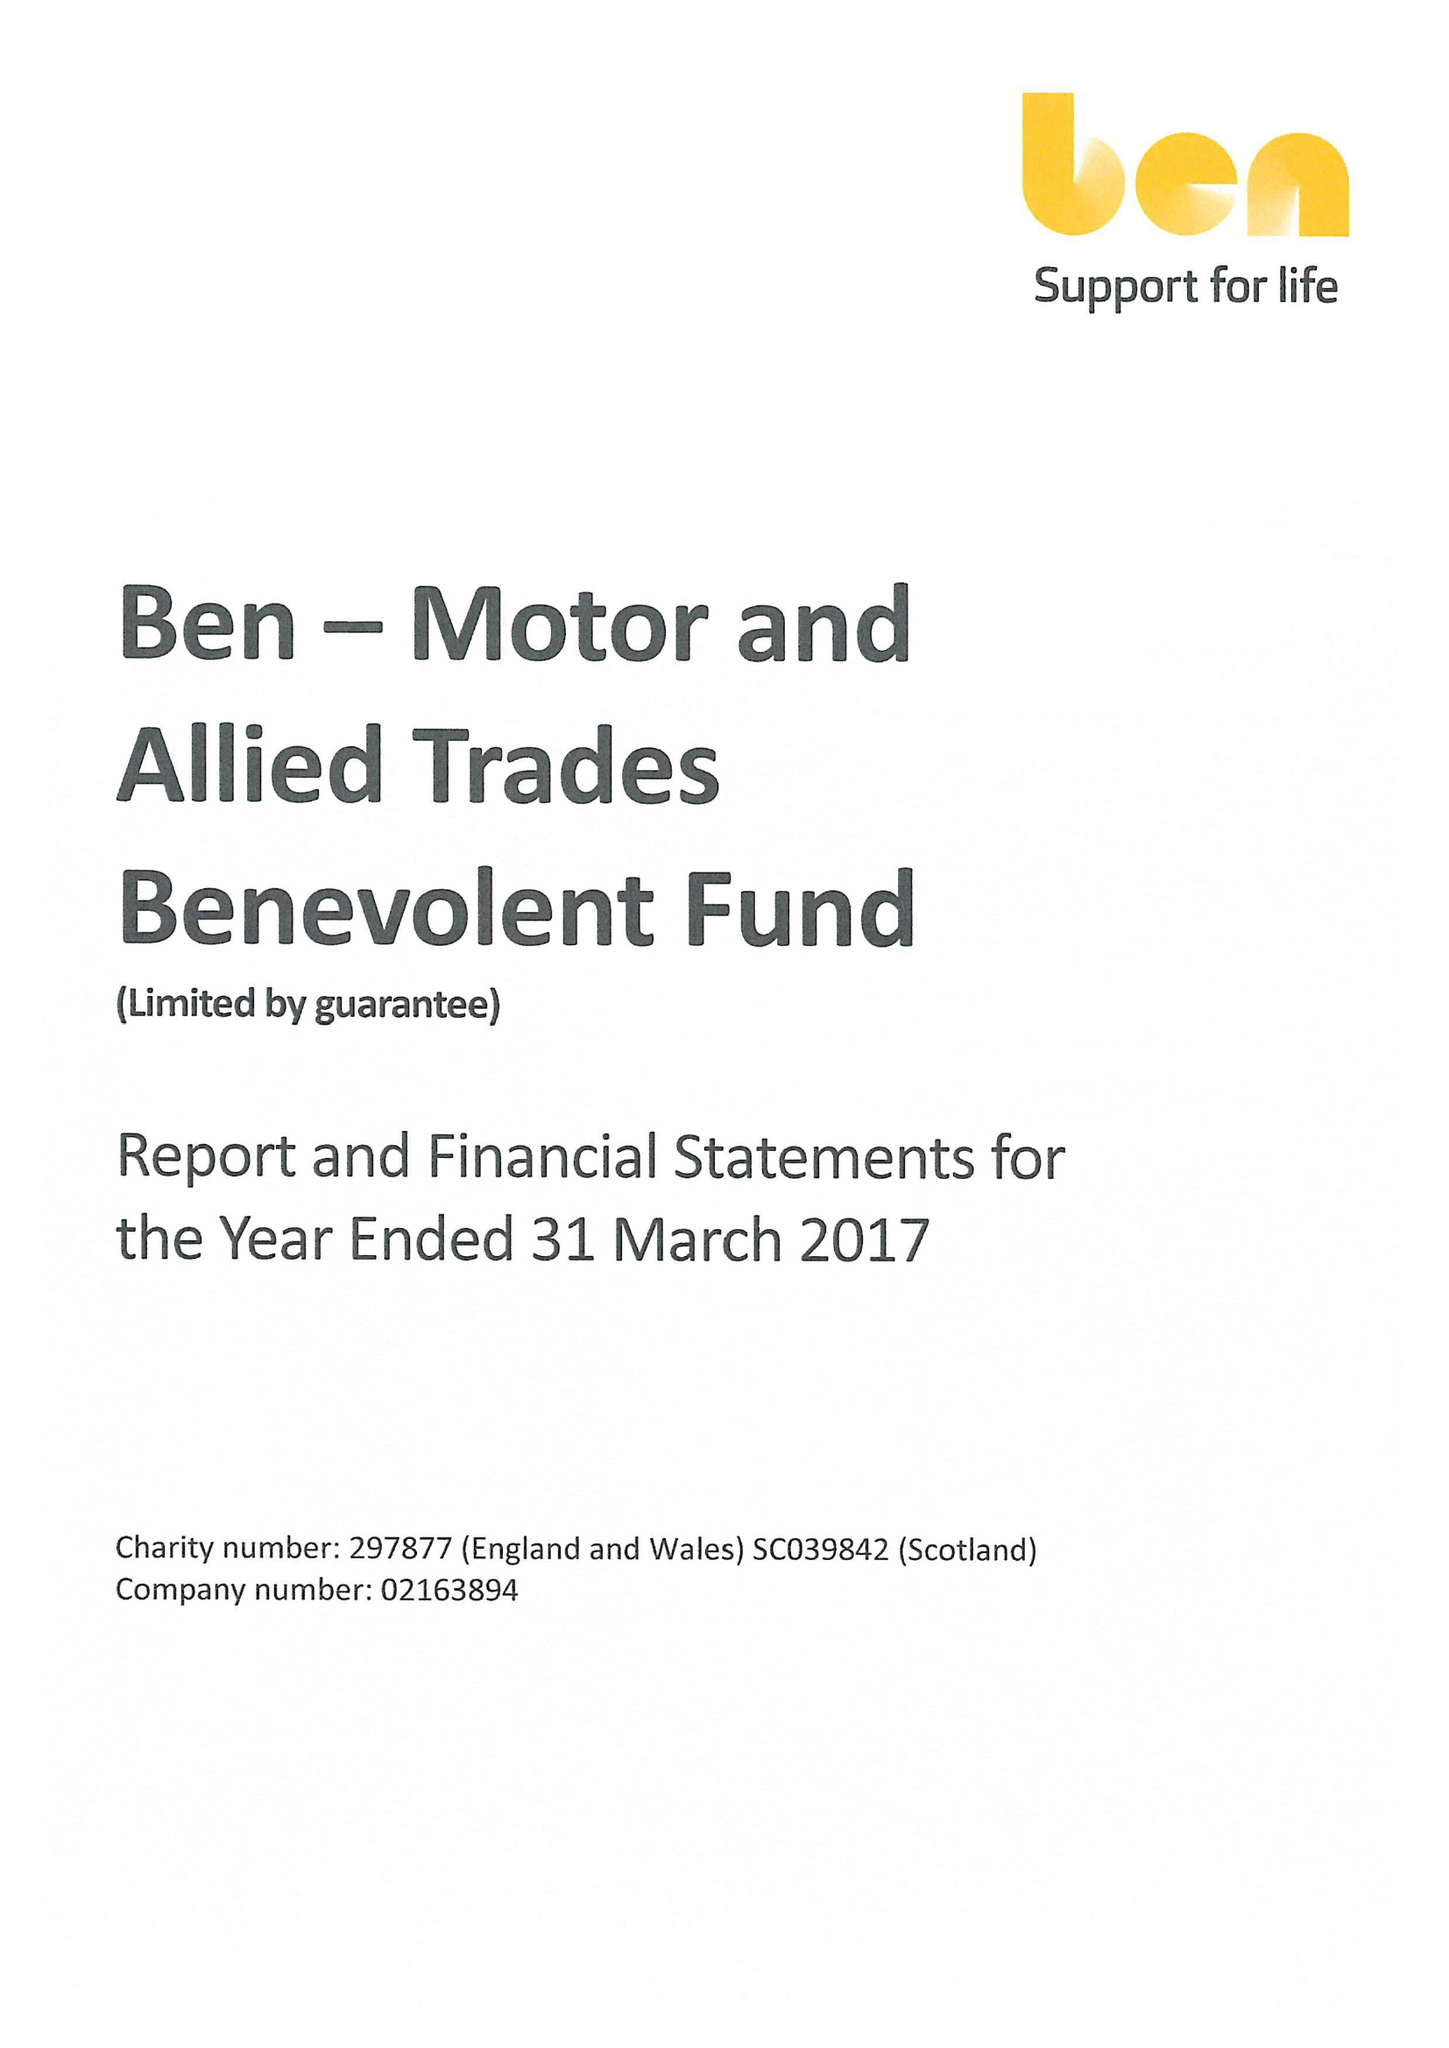What is the value for the report_date?
Answer the question using a single word or phrase. 2017-03-31 